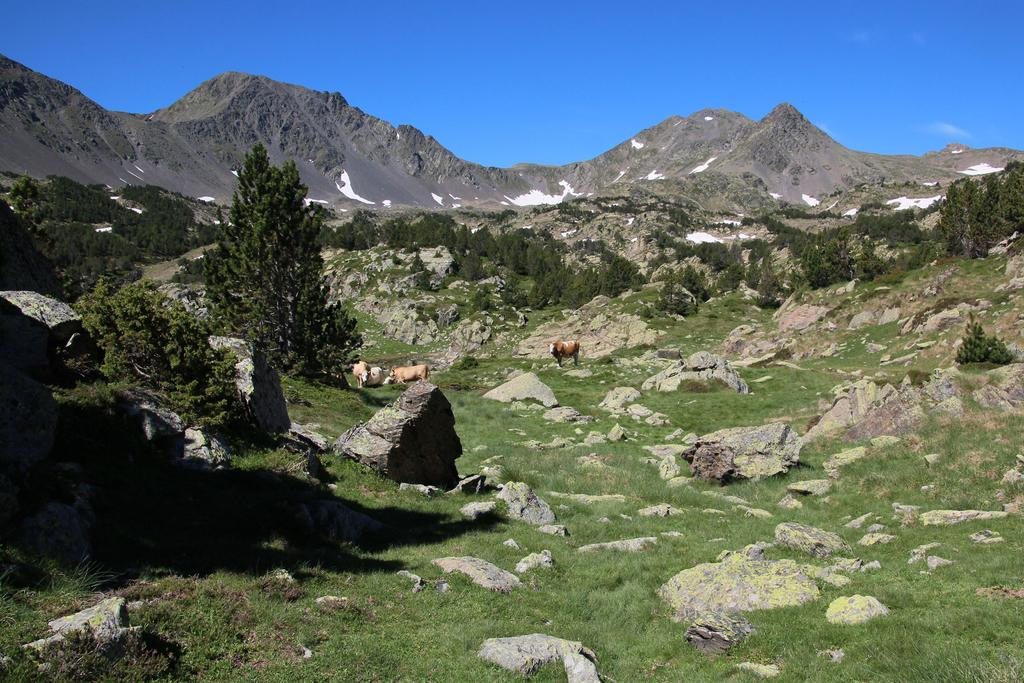What is the main subject of the image? There is a group of animals in the image. What is the position of the animals in the image? The animals are standing on the ground. What can be seen in the background of the image? There is a group of trees and mountains visible in the background of the image. What else is visible in the background of the image? The sky is visible in the background of the image. What type of church can be seen in the image? There is no church present in the image; it features a group of animals standing on the ground with trees, mountains, and the sky visible in the background. 